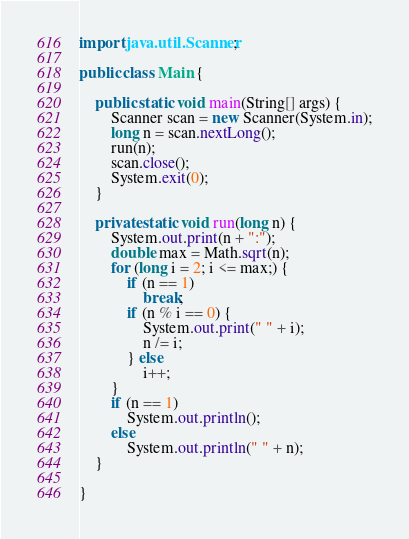<code> <loc_0><loc_0><loc_500><loc_500><_Java_>import java.util.Scanner;

public class Main {

	public static void main(String[] args) {
		Scanner scan = new Scanner(System.in);
		long n = scan.nextLong();
		run(n);
		scan.close();
		System.exit(0);
	}

	private static void run(long n) {
		System.out.print(n + ":");
		double max = Math.sqrt(n);
		for (long i = 2; i <= max;) {
			if (n == 1)
				break;
			if (n % i == 0) {
				System.out.print(" " + i);
				n /= i;
			} else
				i++;
		}
		if (n == 1)
			System.out.println();
		else
			System.out.println(" " + n);
	}

}</code> 